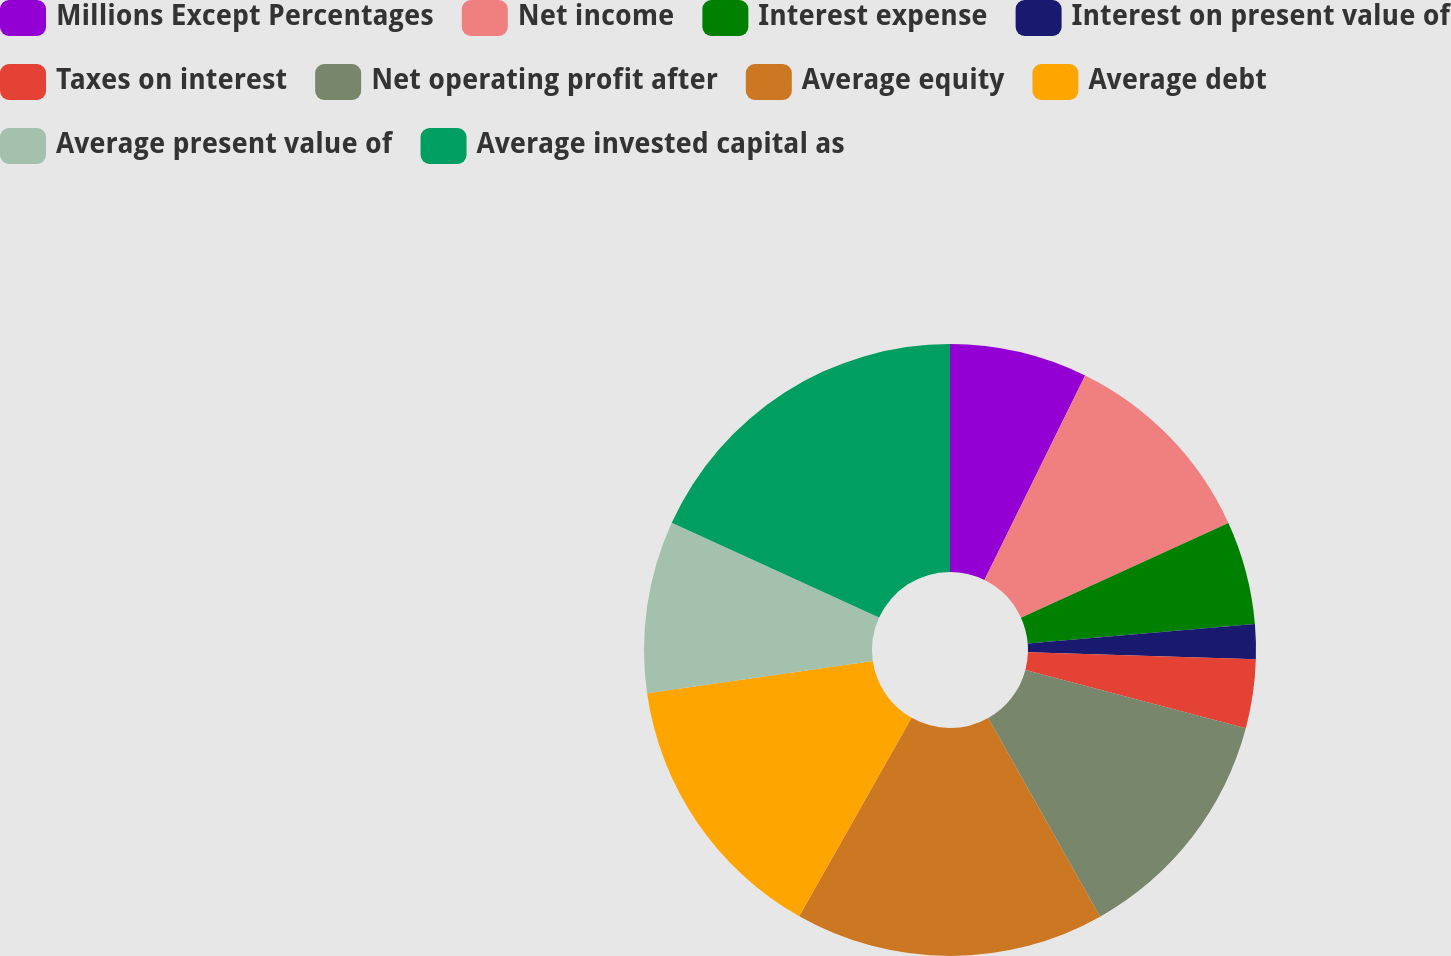<chart> <loc_0><loc_0><loc_500><loc_500><pie_chart><fcel>Millions Except Percentages<fcel>Net income<fcel>Interest expense<fcel>Interest on present value of<fcel>Taxes on interest<fcel>Net operating profit after<fcel>Average equity<fcel>Average debt<fcel>Average present value of<fcel>Average invested capital as<nl><fcel>7.28%<fcel>10.91%<fcel>5.46%<fcel>1.83%<fcel>3.64%<fcel>12.72%<fcel>16.36%<fcel>14.54%<fcel>9.09%<fcel>18.17%<nl></chart> 